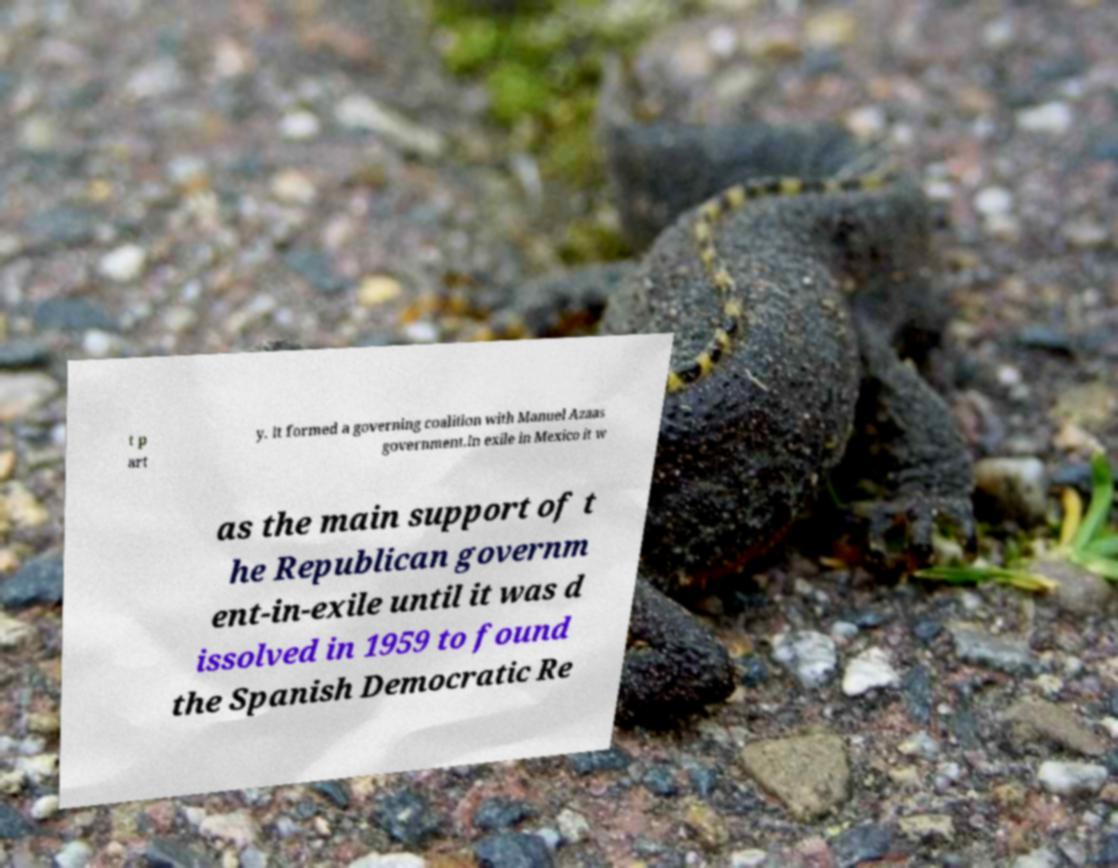Please read and relay the text visible in this image. What does it say? t p art y. It formed a governing coalition with Manuel Azaas government.In exile in Mexico it w as the main support of t he Republican governm ent-in-exile until it was d issolved in 1959 to found the Spanish Democratic Re 